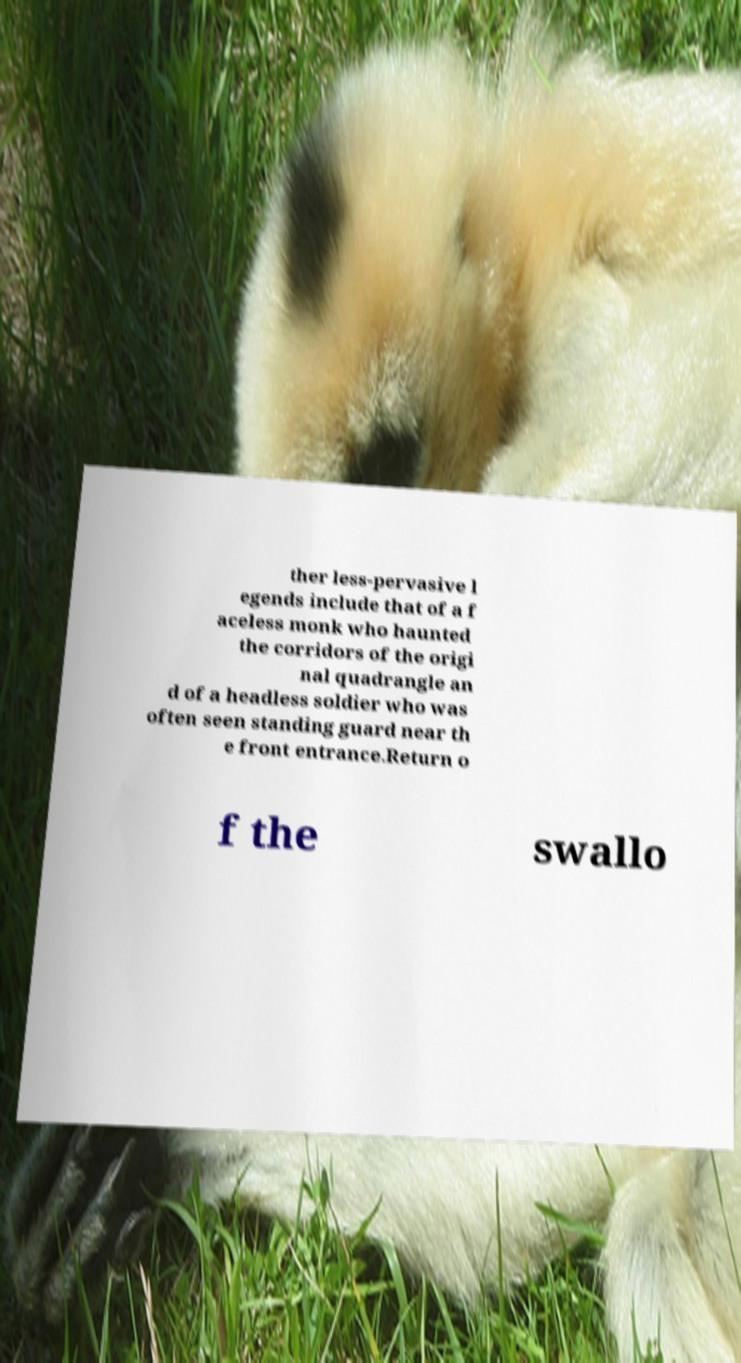Can you accurately transcribe the text from the provided image for me? ther less-pervasive l egends include that of a f aceless monk who haunted the corridors of the origi nal quadrangle an d of a headless soldier who was often seen standing guard near th e front entrance.Return o f the swallo 